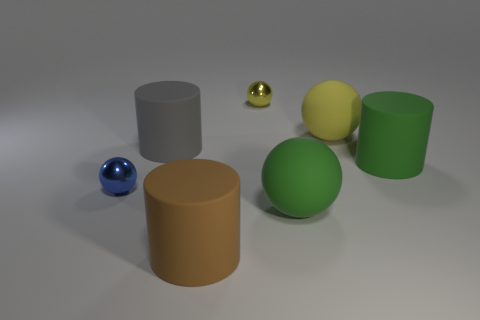What is the material of the other big object that is the same shape as the yellow matte object?
Provide a succinct answer. Rubber. There is a big gray thing to the left of the cylinder on the right side of the big green sphere; what shape is it?
Provide a succinct answer. Cylinder. Is the material of the tiny thing that is on the right side of the small blue metallic object the same as the large brown cylinder?
Give a very brief answer. No. Are there an equal number of small blue metal objects behind the big yellow ball and gray matte cylinders on the right side of the green ball?
Your response must be concise. Yes. There is a small metal ball on the right side of the brown matte object; how many large green balls are on the left side of it?
Offer a very short reply. 0. There is a cylinder that is to the right of the big green sphere; does it have the same color as the big matte ball in front of the gray matte thing?
Give a very brief answer. Yes. What is the material of the yellow thing that is the same size as the gray thing?
Offer a very short reply. Rubber. What shape is the tiny object to the left of the large matte cylinder that is in front of the green ball in front of the big green cylinder?
Offer a very short reply. Sphere. What is the shape of the yellow rubber thing that is the same size as the gray thing?
Provide a succinct answer. Sphere. There is a yellow sphere on the left side of the matte ball that is in front of the blue thing; what number of brown things are behind it?
Make the answer very short. 0. 